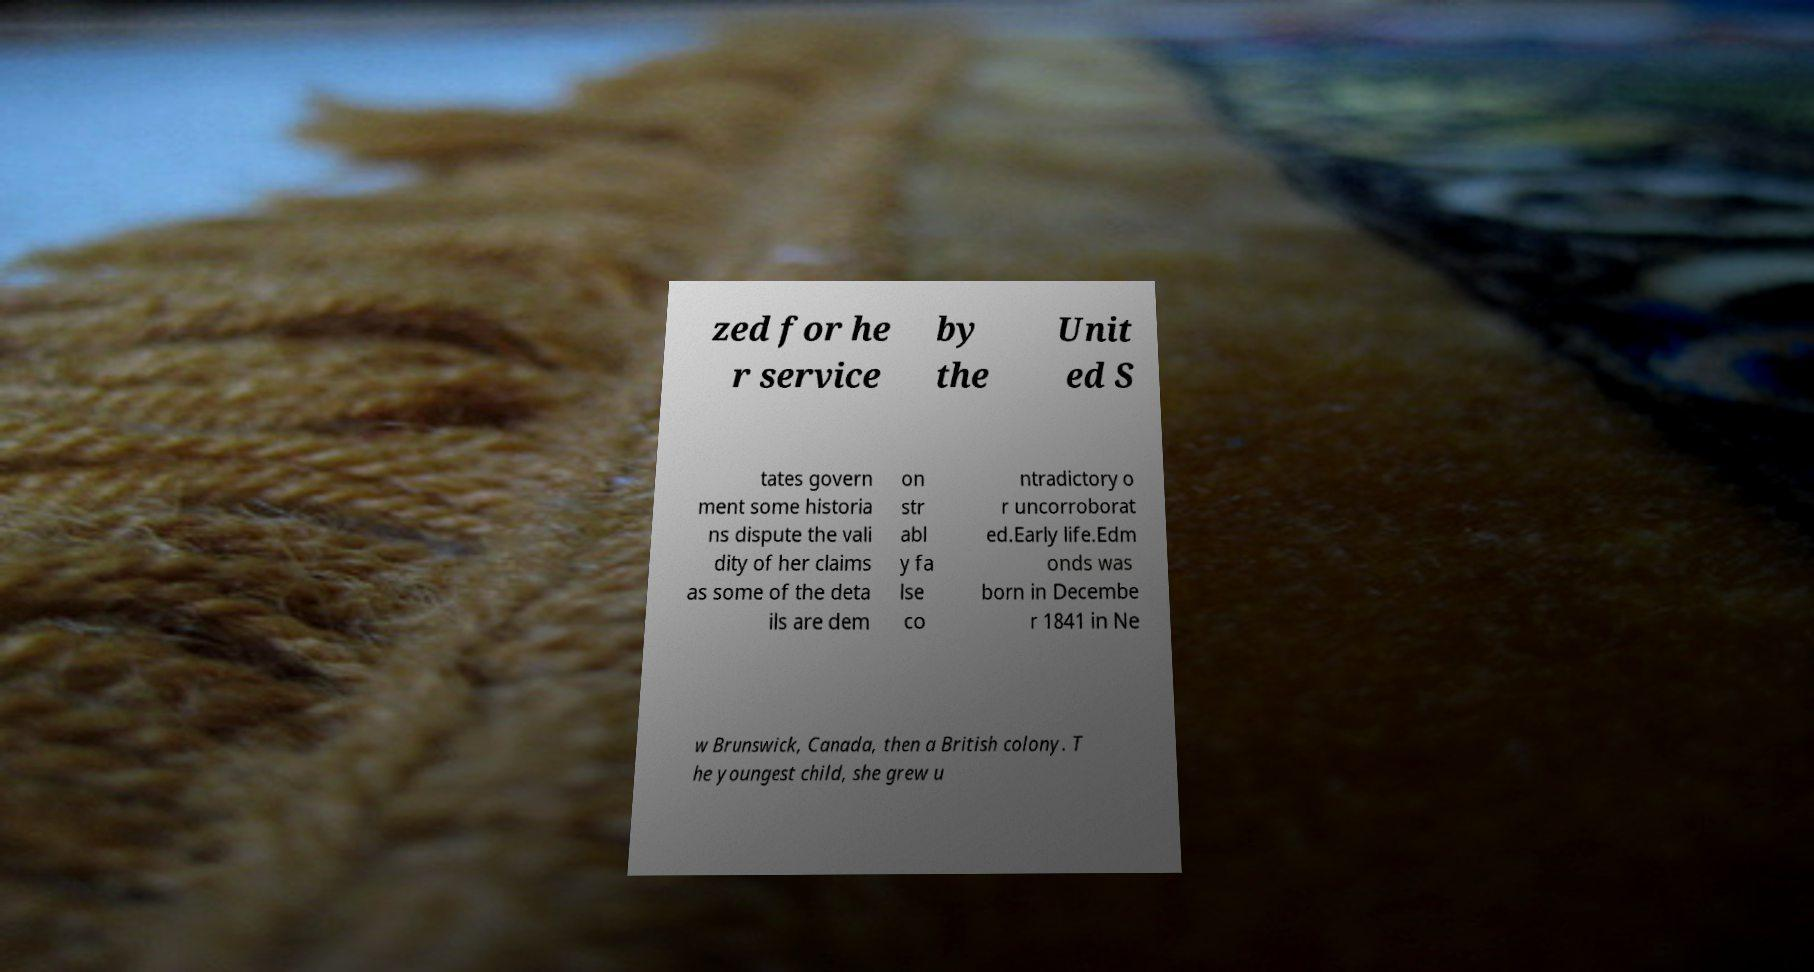Can you accurately transcribe the text from the provided image for me? zed for he r service by the Unit ed S tates govern ment some historia ns dispute the vali dity of her claims as some of the deta ils are dem on str abl y fa lse co ntradictory o r uncorroborat ed.Early life.Edm onds was born in Decembe r 1841 in Ne w Brunswick, Canada, then a British colony. T he youngest child, she grew u 